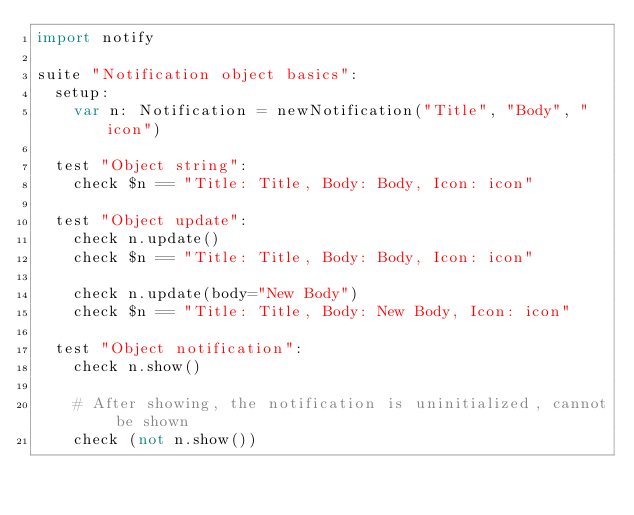<code> <loc_0><loc_0><loc_500><loc_500><_Nim_>import notify

suite "Notification object basics":
  setup:
    var n: Notification = newNotification("Title", "Body", "icon")

  test "Object string":
    check $n == "Title: Title, Body: Body, Icon: icon"

  test "Object update":
    check n.update()
    check $n == "Title: Title, Body: Body, Icon: icon"

    check n.update(body="New Body")
    check $n == "Title: Title, Body: New Body, Icon: icon"

  test "Object notification":
    check n.show()

    # After showing, the notification is uninitialized, cannot be shown
    check (not n.show())
</code> 